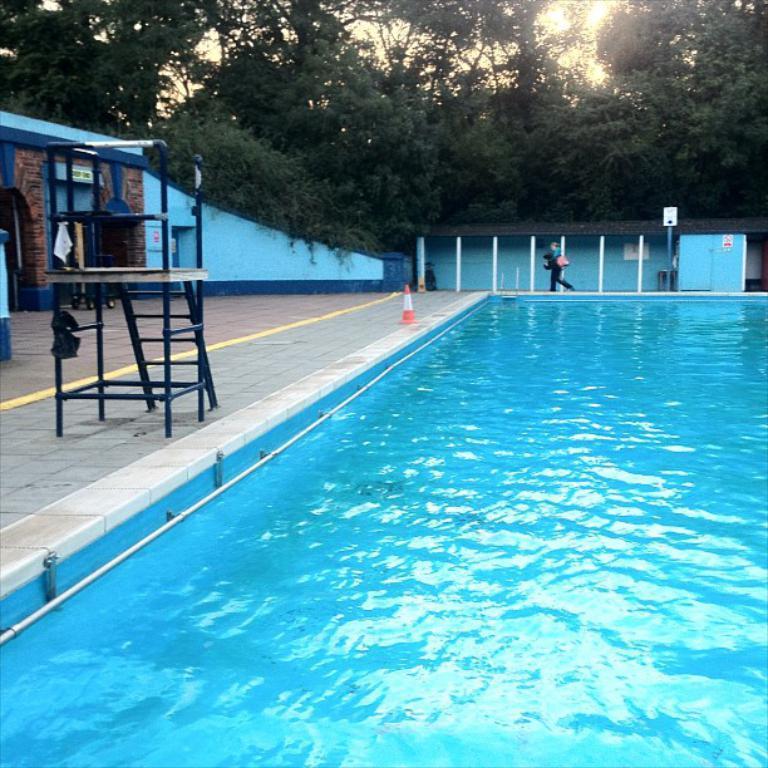Can you describe this image briefly? In the picture I can see a person is walking on the side of a swimming pool. I can also see a traffic cone, poles and some other objects on the floor. In the background I can see trees, the sky and some other objects on the ground. 